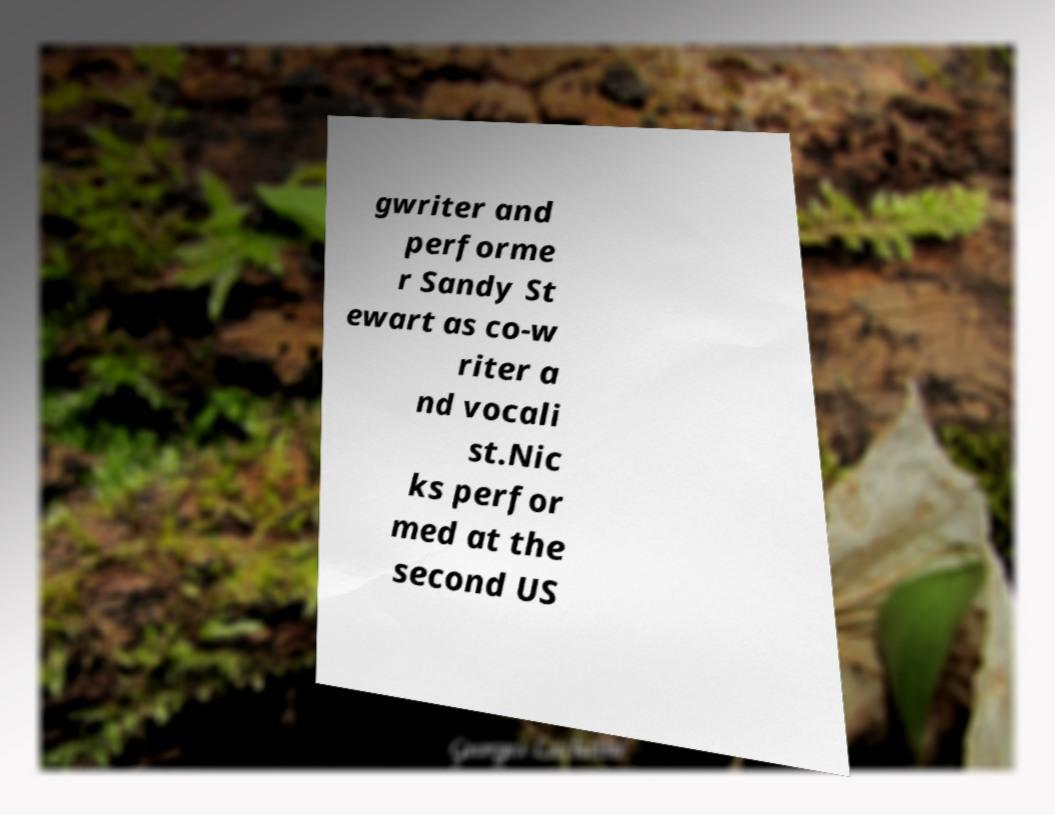There's text embedded in this image that I need extracted. Can you transcribe it verbatim? gwriter and performe r Sandy St ewart as co-w riter a nd vocali st.Nic ks perfor med at the second US 